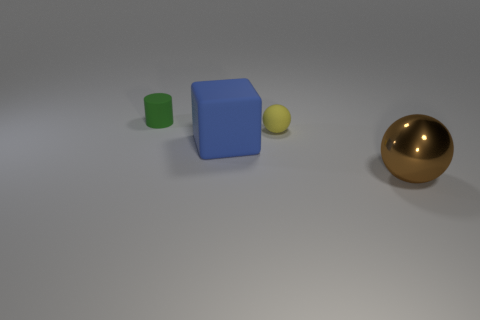How many balls are both on the right side of the tiny yellow matte ball and to the left of the brown metallic object?
Your response must be concise. 0. What is the color of the matte object that is in front of the ball behind the brown metallic object?
Provide a short and direct response. Blue. Is the number of yellow things less than the number of rubber objects?
Your answer should be very brief. Yes. Are there more tiny rubber balls that are in front of the blue object than yellow balls on the left side of the green cylinder?
Your answer should be compact. No. Is the small ball made of the same material as the small cylinder?
Provide a short and direct response. Yes. How many large matte blocks are on the right side of the tiny object to the right of the big blue object?
Keep it short and to the point. 0. What number of things are either large gray metallic cubes or tiny things to the right of the large block?
Offer a terse response. 1. Does the thing that is on the right side of the rubber sphere have the same shape as the small matte thing that is right of the big blue matte block?
Provide a succinct answer. Yes. What shape is the large blue thing that is made of the same material as the tiny ball?
Keep it short and to the point. Cube. There is a thing that is right of the big blue rubber object and behind the blue thing; what is its material?
Keep it short and to the point. Rubber. 